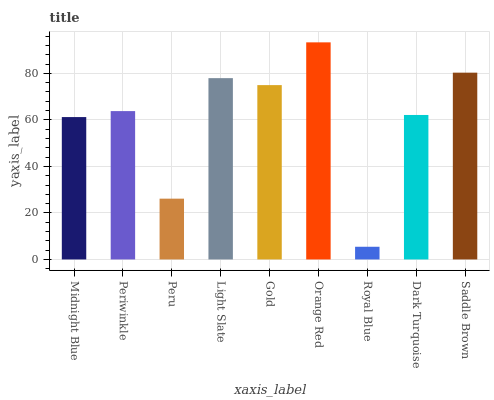Is Royal Blue the minimum?
Answer yes or no. Yes. Is Orange Red the maximum?
Answer yes or no. Yes. Is Periwinkle the minimum?
Answer yes or no. No. Is Periwinkle the maximum?
Answer yes or no. No. Is Periwinkle greater than Midnight Blue?
Answer yes or no. Yes. Is Midnight Blue less than Periwinkle?
Answer yes or no. Yes. Is Midnight Blue greater than Periwinkle?
Answer yes or no. No. Is Periwinkle less than Midnight Blue?
Answer yes or no. No. Is Periwinkle the high median?
Answer yes or no. Yes. Is Periwinkle the low median?
Answer yes or no. Yes. Is Dark Turquoise the high median?
Answer yes or no. No. Is Peru the low median?
Answer yes or no. No. 